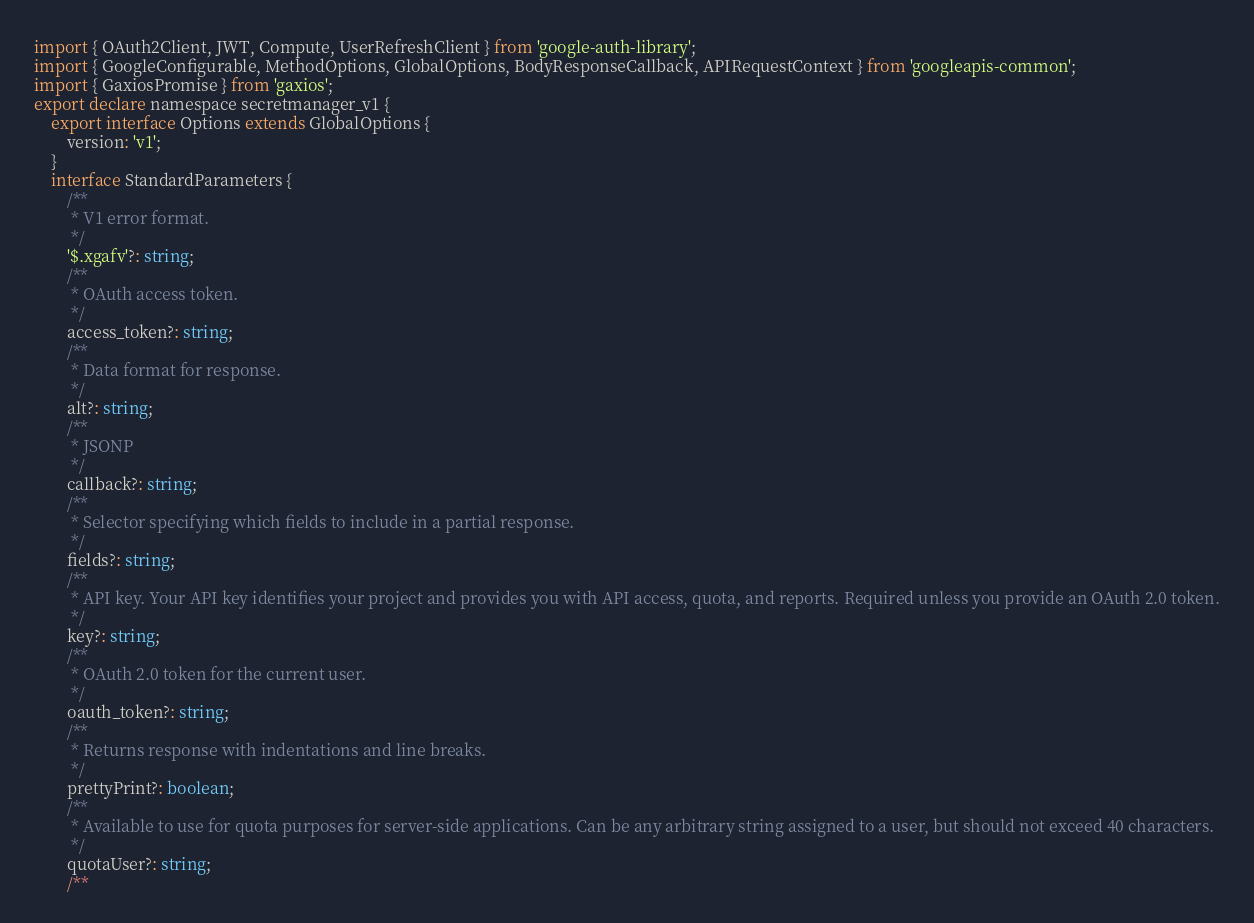Convert code to text. <code><loc_0><loc_0><loc_500><loc_500><_TypeScript_>import { OAuth2Client, JWT, Compute, UserRefreshClient } from 'google-auth-library';
import { GoogleConfigurable, MethodOptions, GlobalOptions, BodyResponseCallback, APIRequestContext } from 'googleapis-common';
import { GaxiosPromise } from 'gaxios';
export declare namespace secretmanager_v1 {
    export interface Options extends GlobalOptions {
        version: 'v1';
    }
    interface StandardParameters {
        /**
         * V1 error format.
         */
        '$.xgafv'?: string;
        /**
         * OAuth access token.
         */
        access_token?: string;
        /**
         * Data format for response.
         */
        alt?: string;
        /**
         * JSONP
         */
        callback?: string;
        /**
         * Selector specifying which fields to include in a partial response.
         */
        fields?: string;
        /**
         * API key. Your API key identifies your project and provides you with API access, quota, and reports. Required unless you provide an OAuth 2.0 token.
         */
        key?: string;
        /**
         * OAuth 2.0 token for the current user.
         */
        oauth_token?: string;
        /**
         * Returns response with indentations and line breaks.
         */
        prettyPrint?: boolean;
        /**
         * Available to use for quota purposes for server-side applications. Can be any arbitrary string assigned to a user, but should not exceed 40 characters.
         */
        quotaUser?: string;
        /**</code> 